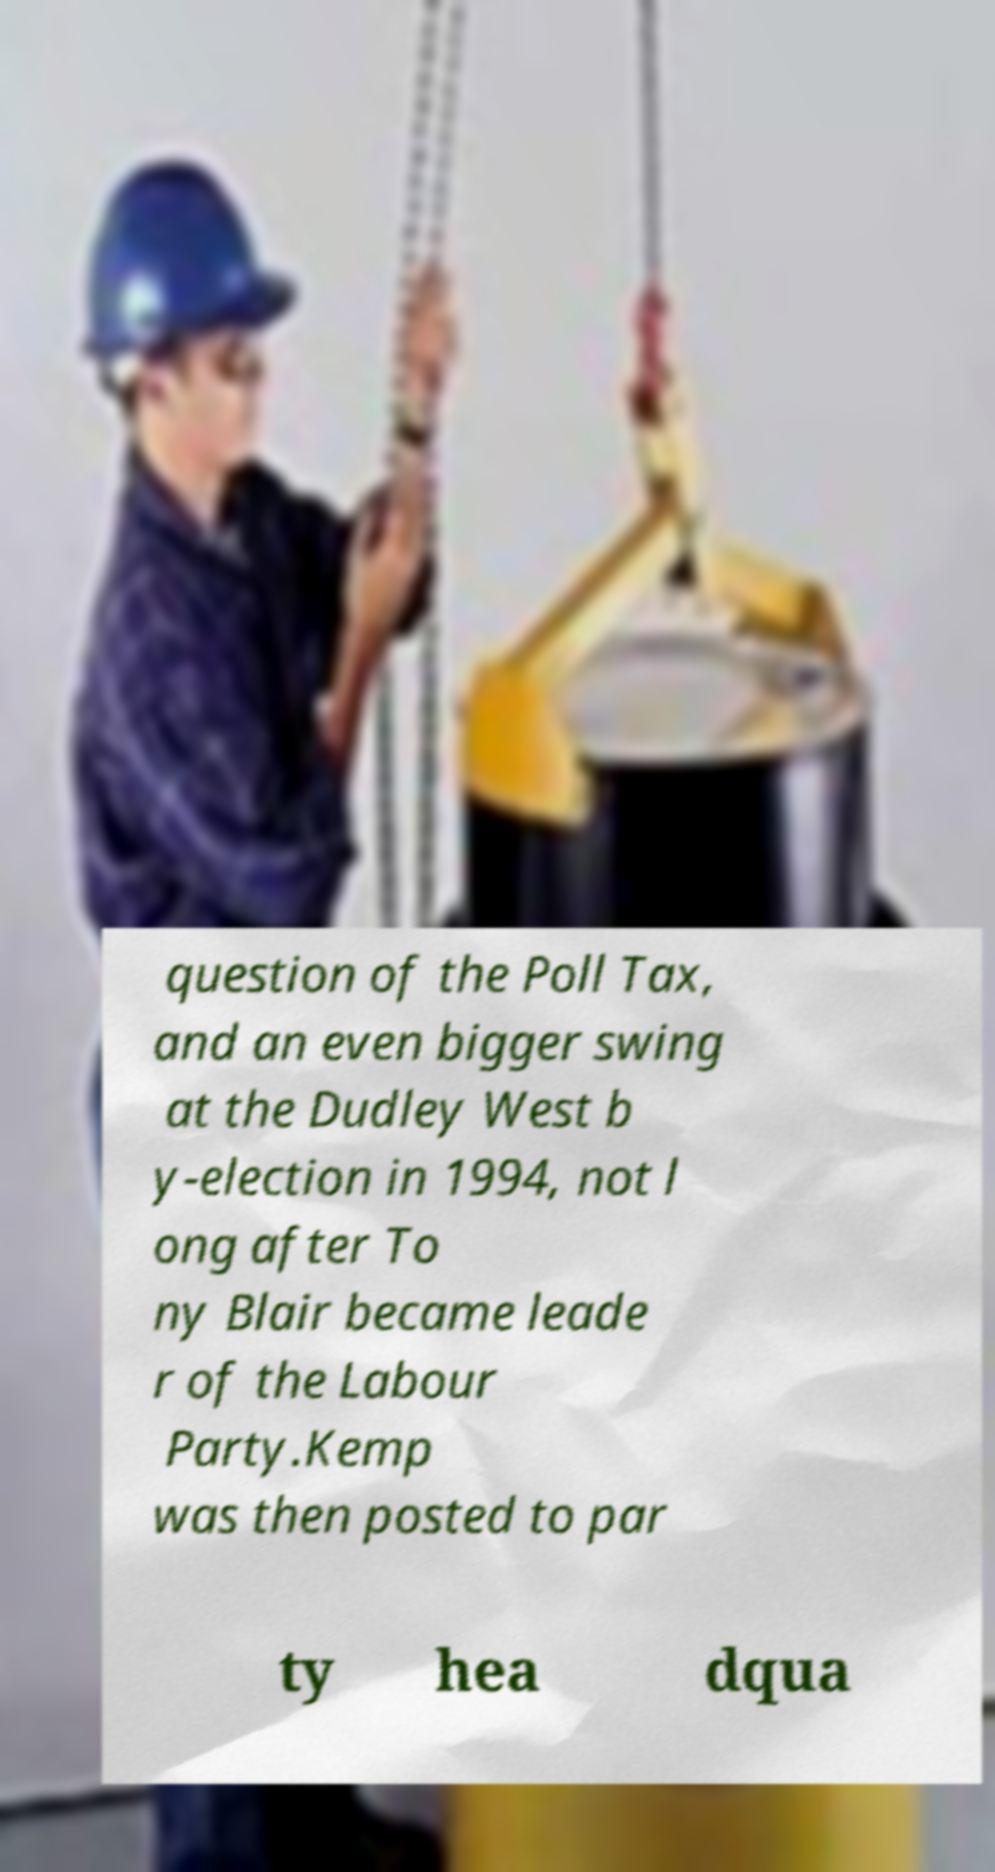Please read and relay the text visible in this image. What does it say? question of the Poll Tax, and an even bigger swing at the Dudley West b y-election in 1994, not l ong after To ny Blair became leade r of the Labour Party.Kemp was then posted to par ty hea dqua 